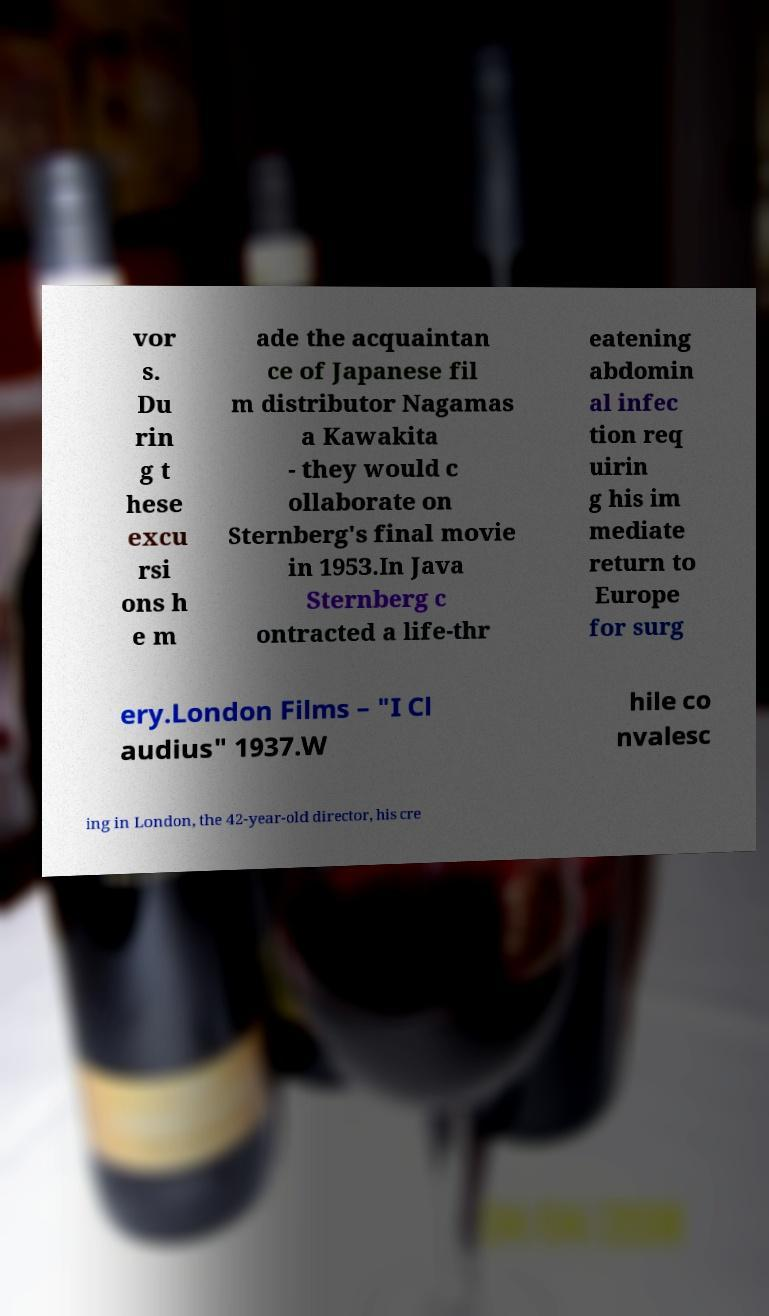Can you accurately transcribe the text from the provided image for me? vor s. Du rin g t hese excu rsi ons h e m ade the acquaintan ce of Japanese fil m distributor Nagamas a Kawakita - they would c ollaborate on Sternberg's final movie in 1953.In Java Sternberg c ontracted a life-thr eatening abdomin al infec tion req uirin g his im mediate return to Europe for surg ery.London Films – "I Cl audius" 1937.W hile co nvalesc ing in London, the 42-year-old director, his cre 